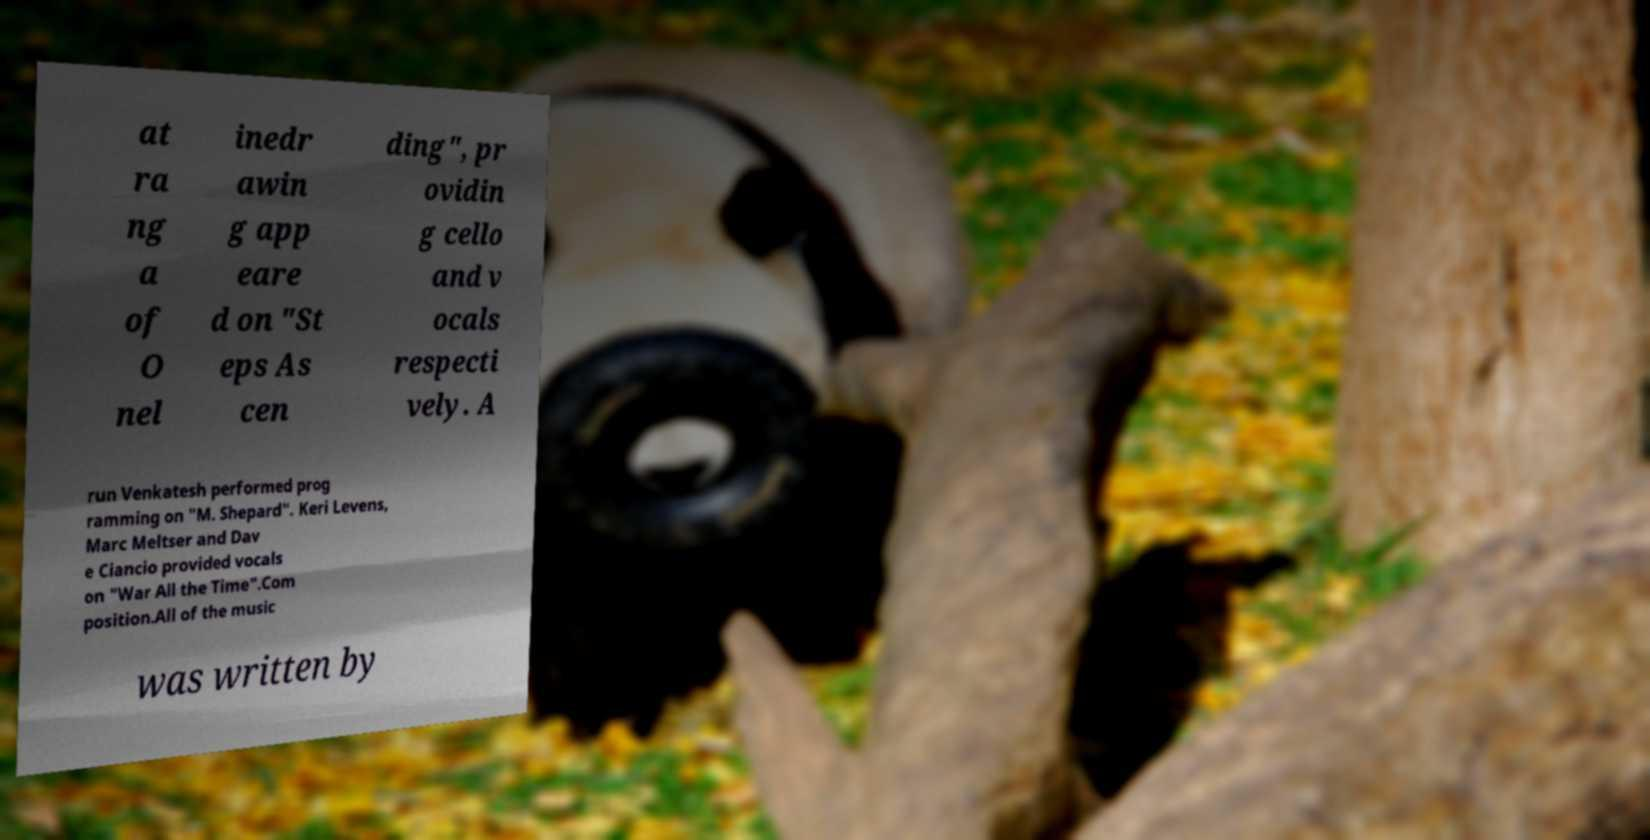Could you assist in decoding the text presented in this image and type it out clearly? at ra ng a of O nel inedr awin g app eare d on "St eps As cen ding", pr ovidin g cello and v ocals respecti vely. A run Venkatesh performed prog ramming on "M. Shepard". Keri Levens, Marc Meltser and Dav e Ciancio provided vocals on "War All the Time".Com position.All of the music was written by 